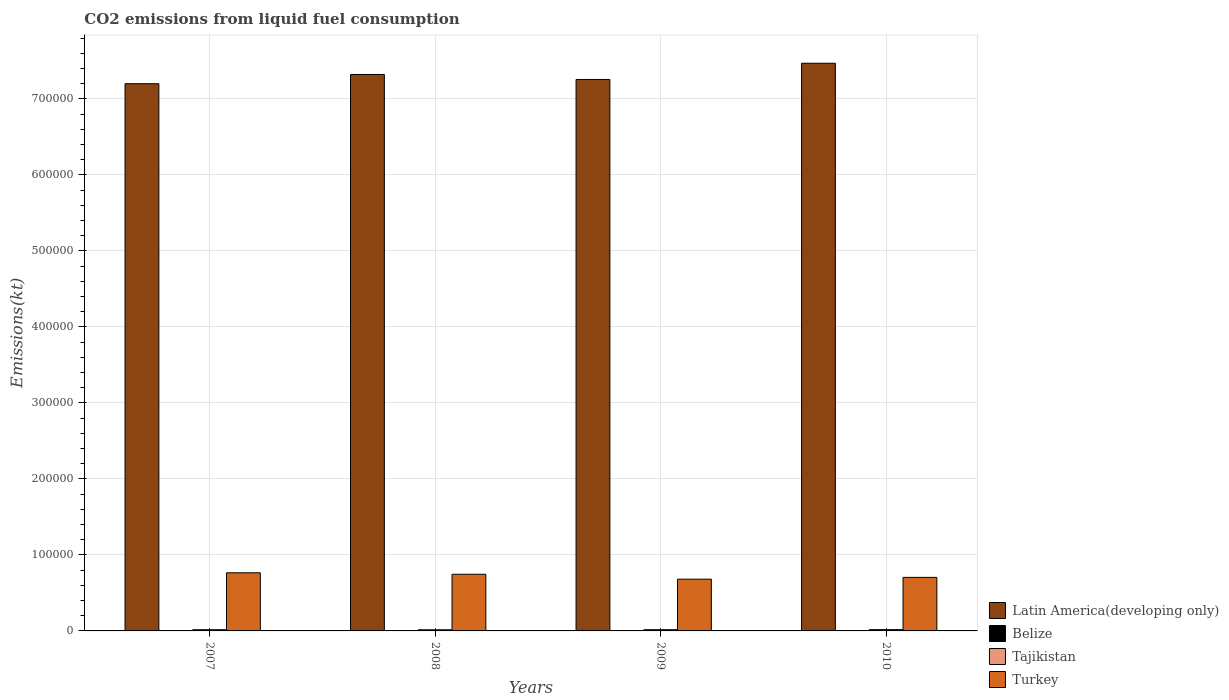Are the number of bars per tick equal to the number of legend labels?
Your response must be concise. Yes. Are the number of bars on each tick of the X-axis equal?
Your answer should be compact. Yes. How many bars are there on the 1st tick from the right?
Provide a succinct answer. 4. What is the label of the 1st group of bars from the left?
Provide a succinct answer. 2007. In how many cases, is the number of bars for a given year not equal to the number of legend labels?
Your response must be concise. 0. What is the amount of CO2 emitted in Latin America(developing only) in 2008?
Give a very brief answer. 7.32e+05. Across all years, what is the maximum amount of CO2 emitted in Latin America(developing only)?
Offer a terse response. 7.47e+05. Across all years, what is the minimum amount of CO2 emitted in Latin America(developing only)?
Your answer should be compact. 7.20e+05. In which year was the amount of CO2 emitted in Belize minimum?
Ensure brevity in your answer.  2008. What is the total amount of CO2 emitted in Belize in the graph?
Your answer should be very brief. 1917.84. What is the difference between the amount of CO2 emitted in Latin America(developing only) in 2008 and that in 2010?
Your answer should be very brief. -1.48e+04. What is the difference between the amount of CO2 emitted in Tajikistan in 2010 and the amount of CO2 emitted in Belize in 2009?
Ensure brevity in your answer.  1224.78. What is the average amount of CO2 emitted in Turkey per year?
Offer a terse response. 7.24e+04. In the year 2008, what is the difference between the amount of CO2 emitted in Turkey and amount of CO2 emitted in Tajikistan?
Offer a very short reply. 7.30e+04. What is the ratio of the amount of CO2 emitted in Latin America(developing only) in 2009 to that in 2010?
Give a very brief answer. 0.97. What is the difference between the highest and the second highest amount of CO2 emitted in Latin America(developing only)?
Provide a short and direct response. 1.48e+04. What is the difference between the highest and the lowest amount of CO2 emitted in Latin America(developing only)?
Provide a succinct answer. 2.69e+04. In how many years, is the amount of CO2 emitted in Turkey greater than the average amount of CO2 emitted in Turkey taken over all years?
Your answer should be compact. 2. Is the sum of the amount of CO2 emitted in Tajikistan in 2007 and 2009 greater than the maximum amount of CO2 emitted in Belize across all years?
Provide a short and direct response. Yes. Is it the case that in every year, the sum of the amount of CO2 emitted in Latin America(developing only) and amount of CO2 emitted in Tajikistan is greater than the sum of amount of CO2 emitted in Belize and amount of CO2 emitted in Turkey?
Provide a short and direct response. Yes. What does the 2nd bar from the left in 2007 represents?
Ensure brevity in your answer.  Belize. Is it the case that in every year, the sum of the amount of CO2 emitted in Turkey and amount of CO2 emitted in Belize is greater than the amount of CO2 emitted in Latin America(developing only)?
Your answer should be compact. No. How many bars are there?
Give a very brief answer. 16. How many years are there in the graph?
Offer a terse response. 4. Does the graph contain any zero values?
Offer a terse response. No. Does the graph contain grids?
Ensure brevity in your answer.  Yes. How many legend labels are there?
Offer a terse response. 4. What is the title of the graph?
Offer a terse response. CO2 emissions from liquid fuel consumption. What is the label or title of the Y-axis?
Your answer should be very brief. Emissions(kt). What is the Emissions(kt) in Latin America(developing only) in 2007?
Your answer should be very brief. 7.20e+05. What is the Emissions(kt) of Belize in 2007?
Your answer should be very brief. 458.38. What is the Emissions(kt) of Tajikistan in 2007?
Make the answer very short. 1587.81. What is the Emissions(kt) in Turkey in 2007?
Offer a terse response. 7.65e+04. What is the Emissions(kt) in Latin America(developing only) in 2008?
Give a very brief answer. 7.32e+05. What is the Emissions(kt) in Belize in 2008?
Your answer should be very brief. 451.04. What is the Emissions(kt) of Tajikistan in 2008?
Your answer should be compact. 1518.14. What is the Emissions(kt) in Turkey in 2008?
Provide a succinct answer. 7.45e+04. What is the Emissions(kt) in Latin America(developing only) in 2009?
Keep it short and to the point. 7.26e+05. What is the Emissions(kt) of Belize in 2009?
Your answer should be very brief. 469.38. What is the Emissions(kt) in Tajikistan in 2009?
Offer a very short reply. 1613.48. What is the Emissions(kt) in Turkey in 2009?
Provide a short and direct response. 6.81e+04. What is the Emissions(kt) of Latin America(developing only) in 2010?
Offer a very short reply. 7.47e+05. What is the Emissions(kt) in Belize in 2010?
Offer a very short reply. 539.05. What is the Emissions(kt) in Tajikistan in 2010?
Offer a very short reply. 1694.15. What is the Emissions(kt) of Turkey in 2010?
Ensure brevity in your answer.  7.04e+04. Across all years, what is the maximum Emissions(kt) in Latin America(developing only)?
Ensure brevity in your answer.  7.47e+05. Across all years, what is the maximum Emissions(kt) in Belize?
Offer a very short reply. 539.05. Across all years, what is the maximum Emissions(kt) of Tajikistan?
Make the answer very short. 1694.15. Across all years, what is the maximum Emissions(kt) of Turkey?
Offer a very short reply. 7.65e+04. Across all years, what is the minimum Emissions(kt) in Latin America(developing only)?
Provide a succinct answer. 7.20e+05. Across all years, what is the minimum Emissions(kt) of Belize?
Offer a very short reply. 451.04. Across all years, what is the minimum Emissions(kt) of Tajikistan?
Ensure brevity in your answer.  1518.14. Across all years, what is the minimum Emissions(kt) of Turkey?
Give a very brief answer. 6.81e+04. What is the total Emissions(kt) of Latin America(developing only) in the graph?
Your answer should be compact. 2.92e+06. What is the total Emissions(kt) of Belize in the graph?
Your response must be concise. 1917.84. What is the total Emissions(kt) in Tajikistan in the graph?
Your answer should be compact. 6413.58. What is the total Emissions(kt) of Turkey in the graph?
Ensure brevity in your answer.  2.90e+05. What is the difference between the Emissions(kt) of Latin America(developing only) in 2007 and that in 2008?
Your response must be concise. -1.21e+04. What is the difference between the Emissions(kt) in Belize in 2007 and that in 2008?
Keep it short and to the point. 7.33. What is the difference between the Emissions(kt) of Tajikistan in 2007 and that in 2008?
Ensure brevity in your answer.  69.67. What is the difference between the Emissions(kt) in Turkey in 2007 and that in 2008?
Provide a succinct answer. 1925.17. What is the difference between the Emissions(kt) of Latin America(developing only) in 2007 and that in 2009?
Keep it short and to the point. -5595.84. What is the difference between the Emissions(kt) in Belize in 2007 and that in 2009?
Provide a succinct answer. -11. What is the difference between the Emissions(kt) of Tajikistan in 2007 and that in 2009?
Make the answer very short. -25.67. What is the difference between the Emissions(kt) of Turkey in 2007 and that in 2009?
Offer a very short reply. 8390.1. What is the difference between the Emissions(kt) in Latin America(developing only) in 2007 and that in 2010?
Provide a short and direct response. -2.69e+04. What is the difference between the Emissions(kt) of Belize in 2007 and that in 2010?
Provide a succinct answer. -80.67. What is the difference between the Emissions(kt) of Tajikistan in 2007 and that in 2010?
Provide a short and direct response. -106.34. What is the difference between the Emissions(kt) in Turkey in 2007 and that in 2010?
Provide a short and direct response. 6035.88. What is the difference between the Emissions(kt) in Latin America(developing only) in 2008 and that in 2009?
Ensure brevity in your answer.  6545.6. What is the difference between the Emissions(kt) in Belize in 2008 and that in 2009?
Offer a very short reply. -18.34. What is the difference between the Emissions(kt) of Tajikistan in 2008 and that in 2009?
Provide a short and direct response. -95.34. What is the difference between the Emissions(kt) in Turkey in 2008 and that in 2009?
Offer a terse response. 6464.92. What is the difference between the Emissions(kt) in Latin America(developing only) in 2008 and that in 2010?
Your answer should be very brief. -1.48e+04. What is the difference between the Emissions(kt) of Belize in 2008 and that in 2010?
Offer a very short reply. -88.01. What is the difference between the Emissions(kt) in Tajikistan in 2008 and that in 2010?
Provide a short and direct response. -176.02. What is the difference between the Emissions(kt) of Turkey in 2008 and that in 2010?
Your answer should be very brief. 4110.71. What is the difference between the Emissions(kt) in Latin America(developing only) in 2009 and that in 2010?
Provide a short and direct response. -2.13e+04. What is the difference between the Emissions(kt) of Belize in 2009 and that in 2010?
Make the answer very short. -69.67. What is the difference between the Emissions(kt) of Tajikistan in 2009 and that in 2010?
Make the answer very short. -80.67. What is the difference between the Emissions(kt) of Turkey in 2009 and that in 2010?
Ensure brevity in your answer.  -2354.21. What is the difference between the Emissions(kt) of Latin America(developing only) in 2007 and the Emissions(kt) of Belize in 2008?
Offer a terse response. 7.19e+05. What is the difference between the Emissions(kt) of Latin America(developing only) in 2007 and the Emissions(kt) of Tajikistan in 2008?
Your response must be concise. 7.18e+05. What is the difference between the Emissions(kt) of Latin America(developing only) in 2007 and the Emissions(kt) of Turkey in 2008?
Offer a very short reply. 6.45e+05. What is the difference between the Emissions(kt) of Belize in 2007 and the Emissions(kt) of Tajikistan in 2008?
Your answer should be compact. -1059.76. What is the difference between the Emissions(kt) of Belize in 2007 and the Emissions(kt) of Turkey in 2008?
Offer a very short reply. -7.41e+04. What is the difference between the Emissions(kt) in Tajikistan in 2007 and the Emissions(kt) in Turkey in 2008?
Your answer should be compact. -7.30e+04. What is the difference between the Emissions(kt) of Latin America(developing only) in 2007 and the Emissions(kt) of Belize in 2009?
Make the answer very short. 7.19e+05. What is the difference between the Emissions(kt) of Latin America(developing only) in 2007 and the Emissions(kt) of Tajikistan in 2009?
Provide a succinct answer. 7.18e+05. What is the difference between the Emissions(kt) of Latin America(developing only) in 2007 and the Emissions(kt) of Turkey in 2009?
Provide a short and direct response. 6.52e+05. What is the difference between the Emissions(kt) in Belize in 2007 and the Emissions(kt) in Tajikistan in 2009?
Offer a very short reply. -1155.11. What is the difference between the Emissions(kt) of Belize in 2007 and the Emissions(kt) of Turkey in 2009?
Give a very brief answer. -6.76e+04. What is the difference between the Emissions(kt) of Tajikistan in 2007 and the Emissions(kt) of Turkey in 2009?
Provide a succinct answer. -6.65e+04. What is the difference between the Emissions(kt) of Latin America(developing only) in 2007 and the Emissions(kt) of Belize in 2010?
Offer a terse response. 7.19e+05. What is the difference between the Emissions(kt) of Latin America(developing only) in 2007 and the Emissions(kt) of Tajikistan in 2010?
Give a very brief answer. 7.18e+05. What is the difference between the Emissions(kt) of Latin America(developing only) in 2007 and the Emissions(kt) of Turkey in 2010?
Offer a terse response. 6.49e+05. What is the difference between the Emissions(kt) in Belize in 2007 and the Emissions(kt) in Tajikistan in 2010?
Provide a short and direct response. -1235.78. What is the difference between the Emissions(kt) of Belize in 2007 and the Emissions(kt) of Turkey in 2010?
Your response must be concise. -7.00e+04. What is the difference between the Emissions(kt) of Tajikistan in 2007 and the Emissions(kt) of Turkey in 2010?
Provide a succinct answer. -6.88e+04. What is the difference between the Emissions(kt) of Latin America(developing only) in 2008 and the Emissions(kt) of Belize in 2009?
Offer a terse response. 7.32e+05. What is the difference between the Emissions(kt) of Latin America(developing only) in 2008 and the Emissions(kt) of Tajikistan in 2009?
Offer a very short reply. 7.30e+05. What is the difference between the Emissions(kt) of Latin America(developing only) in 2008 and the Emissions(kt) of Turkey in 2009?
Your answer should be very brief. 6.64e+05. What is the difference between the Emissions(kt) of Belize in 2008 and the Emissions(kt) of Tajikistan in 2009?
Ensure brevity in your answer.  -1162.44. What is the difference between the Emissions(kt) of Belize in 2008 and the Emissions(kt) of Turkey in 2009?
Offer a very short reply. -6.76e+04. What is the difference between the Emissions(kt) of Tajikistan in 2008 and the Emissions(kt) of Turkey in 2009?
Your answer should be compact. -6.66e+04. What is the difference between the Emissions(kt) of Latin America(developing only) in 2008 and the Emissions(kt) of Belize in 2010?
Offer a terse response. 7.32e+05. What is the difference between the Emissions(kt) of Latin America(developing only) in 2008 and the Emissions(kt) of Tajikistan in 2010?
Offer a very short reply. 7.30e+05. What is the difference between the Emissions(kt) of Latin America(developing only) in 2008 and the Emissions(kt) of Turkey in 2010?
Your answer should be very brief. 6.62e+05. What is the difference between the Emissions(kt) in Belize in 2008 and the Emissions(kt) in Tajikistan in 2010?
Make the answer very short. -1243.11. What is the difference between the Emissions(kt) in Belize in 2008 and the Emissions(kt) in Turkey in 2010?
Keep it short and to the point. -7.00e+04. What is the difference between the Emissions(kt) of Tajikistan in 2008 and the Emissions(kt) of Turkey in 2010?
Offer a very short reply. -6.89e+04. What is the difference between the Emissions(kt) of Latin America(developing only) in 2009 and the Emissions(kt) of Belize in 2010?
Your answer should be compact. 7.25e+05. What is the difference between the Emissions(kt) in Latin America(developing only) in 2009 and the Emissions(kt) in Tajikistan in 2010?
Ensure brevity in your answer.  7.24e+05. What is the difference between the Emissions(kt) in Latin America(developing only) in 2009 and the Emissions(kt) in Turkey in 2010?
Your response must be concise. 6.55e+05. What is the difference between the Emissions(kt) in Belize in 2009 and the Emissions(kt) in Tajikistan in 2010?
Offer a very short reply. -1224.78. What is the difference between the Emissions(kt) in Belize in 2009 and the Emissions(kt) in Turkey in 2010?
Your answer should be very brief. -7.00e+04. What is the difference between the Emissions(kt) of Tajikistan in 2009 and the Emissions(kt) of Turkey in 2010?
Give a very brief answer. -6.88e+04. What is the average Emissions(kt) in Latin America(developing only) per year?
Provide a short and direct response. 7.31e+05. What is the average Emissions(kt) in Belize per year?
Make the answer very short. 479.46. What is the average Emissions(kt) of Tajikistan per year?
Keep it short and to the point. 1603.4. What is the average Emissions(kt) of Turkey per year?
Your answer should be very brief. 7.24e+04. In the year 2007, what is the difference between the Emissions(kt) of Latin America(developing only) and Emissions(kt) of Belize?
Make the answer very short. 7.19e+05. In the year 2007, what is the difference between the Emissions(kt) in Latin America(developing only) and Emissions(kt) in Tajikistan?
Provide a short and direct response. 7.18e+05. In the year 2007, what is the difference between the Emissions(kt) of Latin America(developing only) and Emissions(kt) of Turkey?
Give a very brief answer. 6.43e+05. In the year 2007, what is the difference between the Emissions(kt) of Belize and Emissions(kt) of Tajikistan?
Offer a very short reply. -1129.44. In the year 2007, what is the difference between the Emissions(kt) of Belize and Emissions(kt) of Turkey?
Offer a terse response. -7.60e+04. In the year 2007, what is the difference between the Emissions(kt) in Tajikistan and Emissions(kt) in Turkey?
Offer a very short reply. -7.49e+04. In the year 2008, what is the difference between the Emissions(kt) in Latin America(developing only) and Emissions(kt) in Belize?
Ensure brevity in your answer.  7.32e+05. In the year 2008, what is the difference between the Emissions(kt) of Latin America(developing only) and Emissions(kt) of Tajikistan?
Keep it short and to the point. 7.31e+05. In the year 2008, what is the difference between the Emissions(kt) of Latin America(developing only) and Emissions(kt) of Turkey?
Provide a short and direct response. 6.58e+05. In the year 2008, what is the difference between the Emissions(kt) of Belize and Emissions(kt) of Tajikistan?
Offer a terse response. -1067.1. In the year 2008, what is the difference between the Emissions(kt) in Belize and Emissions(kt) in Turkey?
Give a very brief answer. -7.41e+04. In the year 2008, what is the difference between the Emissions(kt) in Tajikistan and Emissions(kt) in Turkey?
Make the answer very short. -7.30e+04. In the year 2009, what is the difference between the Emissions(kt) in Latin America(developing only) and Emissions(kt) in Belize?
Give a very brief answer. 7.25e+05. In the year 2009, what is the difference between the Emissions(kt) of Latin America(developing only) and Emissions(kt) of Tajikistan?
Offer a very short reply. 7.24e+05. In the year 2009, what is the difference between the Emissions(kt) in Latin America(developing only) and Emissions(kt) in Turkey?
Give a very brief answer. 6.57e+05. In the year 2009, what is the difference between the Emissions(kt) of Belize and Emissions(kt) of Tajikistan?
Keep it short and to the point. -1144.1. In the year 2009, what is the difference between the Emissions(kt) of Belize and Emissions(kt) of Turkey?
Ensure brevity in your answer.  -6.76e+04. In the year 2009, what is the difference between the Emissions(kt) in Tajikistan and Emissions(kt) in Turkey?
Ensure brevity in your answer.  -6.65e+04. In the year 2010, what is the difference between the Emissions(kt) in Latin America(developing only) and Emissions(kt) in Belize?
Give a very brief answer. 7.46e+05. In the year 2010, what is the difference between the Emissions(kt) of Latin America(developing only) and Emissions(kt) of Tajikistan?
Provide a succinct answer. 7.45e+05. In the year 2010, what is the difference between the Emissions(kt) of Latin America(developing only) and Emissions(kt) of Turkey?
Give a very brief answer. 6.76e+05. In the year 2010, what is the difference between the Emissions(kt) of Belize and Emissions(kt) of Tajikistan?
Keep it short and to the point. -1155.11. In the year 2010, what is the difference between the Emissions(kt) of Belize and Emissions(kt) of Turkey?
Provide a short and direct response. -6.99e+04. In the year 2010, what is the difference between the Emissions(kt) of Tajikistan and Emissions(kt) of Turkey?
Offer a very short reply. -6.87e+04. What is the ratio of the Emissions(kt) of Latin America(developing only) in 2007 to that in 2008?
Your answer should be compact. 0.98. What is the ratio of the Emissions(kt) of Belize in 2007 to that in 2008?
Offer a terse response. 1.02. What is the ratio of the Emissions(kt) in Tajikistan in 2007 to that in 2008?
Your answer should be compact. 1.05. What is the ratio of the Emissions(kt) of Turkey in 2007 to that in 2008?
Make the answer very short. 1.03. What is the ratio of the Emissions(kt) in Belize in 2007 to that in 2009?
Your answer should be very brief. 0.98. What is the ratio of the Emissions(kt) of Tajikistan in 2007 to that in 2009?
Your answer should be very brief. 0.98. What is the ratio of the Emissions(kt) in Turkey in 2007 to that in 2009?
Your response must be concise. 1.12. What is the ratio of the Emissions(kt) of Belize in 2007 to that in 2010?
Your answer should be compact. 0.85. What is the ratio of the Emissions(kt) in Tajikistan in 2007 to that in 2010?
Offer a terse response. 0.94. What is the ratio of the Emissions(kt) in Turkey in 2007 to that in 2010?
Your answer should be compact. 1.09. What is the ratio of the Emissions(kt) in Belize in 2008 to that in 2009?
Keep it short and to the point. 0.96. What is the ratio of the Emissions(kt) in Tajikistan in 2008 to that in 2009?
Ensure brevity in your answer.  0.94. What is the ratio of the Emissions(kt) in Turkey in 2008 to that in 2009?
Provide a succinct answer. 1.09. What is the ratio of the Emissions(kt) of Latin America(developing only) in 2008 to that in 2010?
Offer a terse response. 0.98. What is the ratio of the Emissions(kt) of Belize in 2008 to that in 2010?
Ensure brevity in your answer.  0.84. What is the ratio of the Emissions(kt) of Tajikistan in 2008 to that in 2010?
Offer a very short reply. 0.9. What is the ratio of the Emissions(kt) in Turkey in 2008 to that in 2010?
Your response must be concise. 1.06. What is the ratio of the Emissions(kt) in Latin America(developing only) in 2009 to that in 2010?
Make the answer very short. 0.97. What is the ratio of the Emissions(kt) of Belize in 2009 to that in 2010?
Your answer should be very brief. 0.87. What is the ratio of the Emissions(kt) in Tajikistan in 2009 to that in 2010?
Offer a terse response. 0.95. What is the ratio of the Emissions(kt) of Turkey in 2009 to that in 2010?
Offer a very short reply. 0.97. What is the difference between the highest and the second highest Emissions(kt) of Latin America(developing only)?
Offer a very short reply. 1.48e+04. What is the difference between the highest and the second highest Emissions(kt) of Belize?
Ensure brevity in your answer.  69.67. What is the difference between the highest and the second highest Emissions(kt) of Tajikistan?
Ensure brevity in your answer.  80.67. What is the difference between the highest and the second highest Emissions(kt) of Turkey?
Offer a very short reply. 1925.17. What is the difference between the highest and the lowest Emissions(kt) in Latin America(developing only)?
Provide a succinct answer. 2.69e+04. What is the difference between the highest and the lowest Emissions(kt) in Belize?
Provide a succinct answer. 88.01. What is the difference between the highest and the lowest Emissions(kt) of Tajikistan?
Make the answer very short. 176.02. What is the difference between the highest and the lowest Emissions(kt) of Turkey?
Provide a succinct answer. 8390.1. 